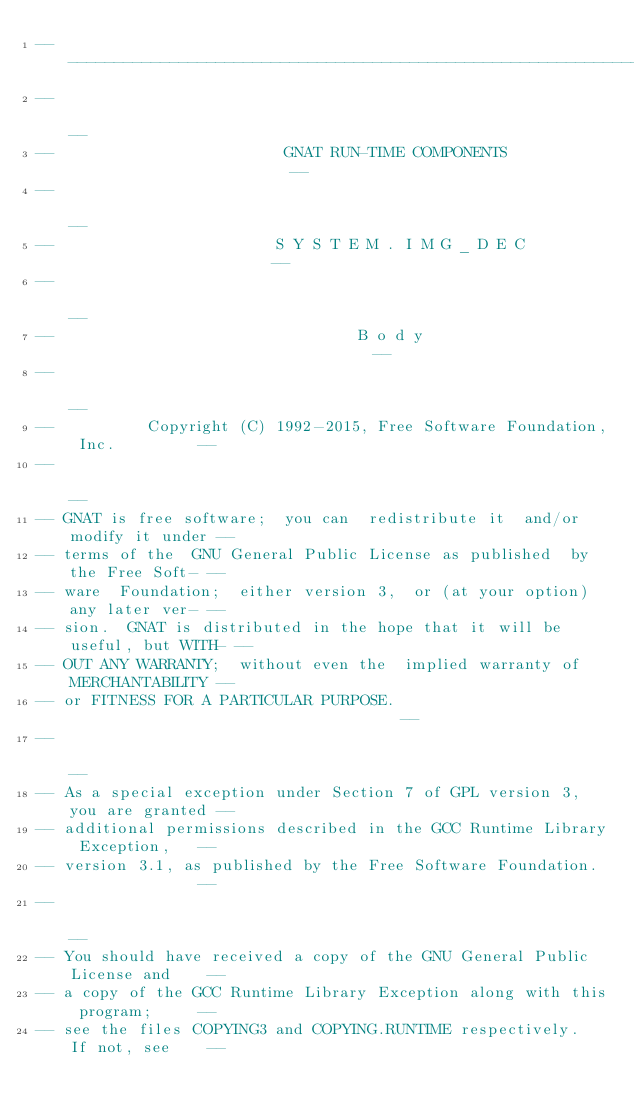Convert code to text. <code><loc_0><loc_0><loc_500><loc_500><_Ada_>------------------------------------------------------------------------------
--                                                                          --
--                         GNAT RUN-TIME COMPONENTS                         --
--                                                                          --
--                        S Y S T E M . I M G _ D E C                       --
--                                                                          --
--                                 B o d y                                  --
--                                                                          --
--          Copyright (C) 1992-2015, Free Software Foundation, Inc.         --
--                                                                          --
-- GNAT is free software;  you can  redistribute it  and/or modify it under --
-- terms of the  GNU General Public License as published  by the Free Soft- --
-- ware  Foundation;  either version 3,  or (at your option) any later ver- --
-- sion.  GNAT is distributed in the hope that it will be useful, but WITH- --
-- OUT ANY WARRANTY;  without even the  implied warranty of MERCHANTABILITY --
-- or FITNESS FOR A PARTICULAR PURPOSE.                                     --
--                                                                          --
-- As a special exception under Section 7 of GPL version 3, you are granted --
-- additional permissions described in the GCC Runtime Library Exception,   --
-- version 3.1, as published by the Free Software Foundation.               --
--                                                                          --
-- You should have received a copy of the GNU General Public License and    --
-- a copy of the GCC Runtime Library Exception along with this program;     --
-- see the files COPYING3 and COPYING.RUNTIME respectively.  If not, see    --</code> 